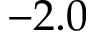<formula> <loc_0><loc_0><loc_500><loc_500>- 2 . 0</formula> 